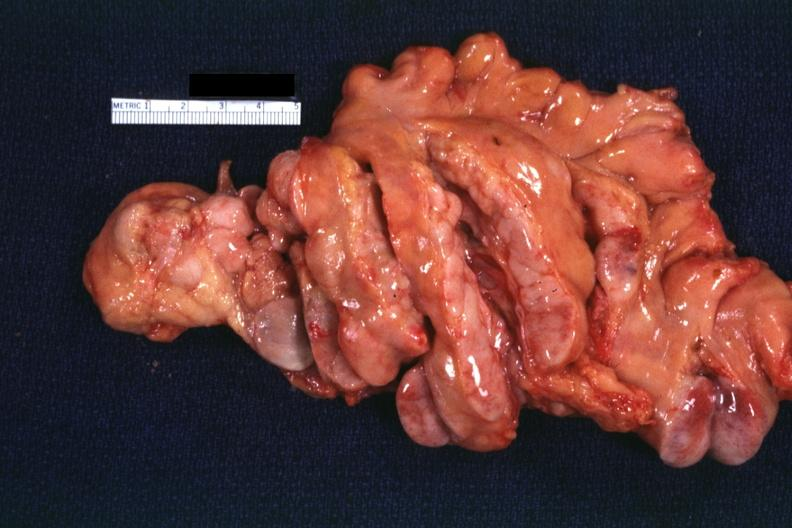how does this image show rather good view of mesentery?
Answer the question using a single word or phrase. With typical large nodes case which may have been a t-cell lymphoma 